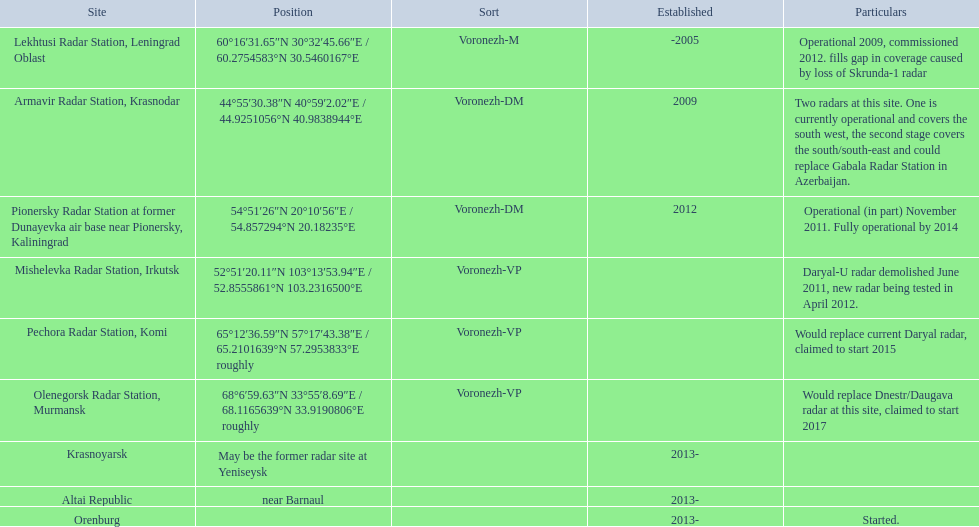Voronezh radar has locations where? Lekhtusi Radar Station, Leningrad Oblast, Armavir Radar Station, Krasnodar, Pionersky Radar Station at former Dunayevka air base near Pionersky, Kaliningrad, Mishelevka Radar Station, Irkutsk, Pechora Radar Station, Komi, Olenegorsk Radar Station, Murmansk, Krasnoyarsk, Altai Republic, Orenburg. Which of these locations have know coordinates? Lekhtusi Radar Station, Leningrad Oblast, Armavir Radar Station, Krasnodar, Pionersky Radar Station at former Dunayevka air base near Pionersky, Kaliningrad, Mishelevka Radar Station, Irkutsk, Pechora Radar Station, Komi, Olenegorsk Radar Station, Murmansk. Which of these locations has coordinates of 60deg16'31.65''n 30deg32'45.66''e / 60.2754583degn 30.5460167dege? Lekhtusi Radar Station, Leningrad Oblast. 